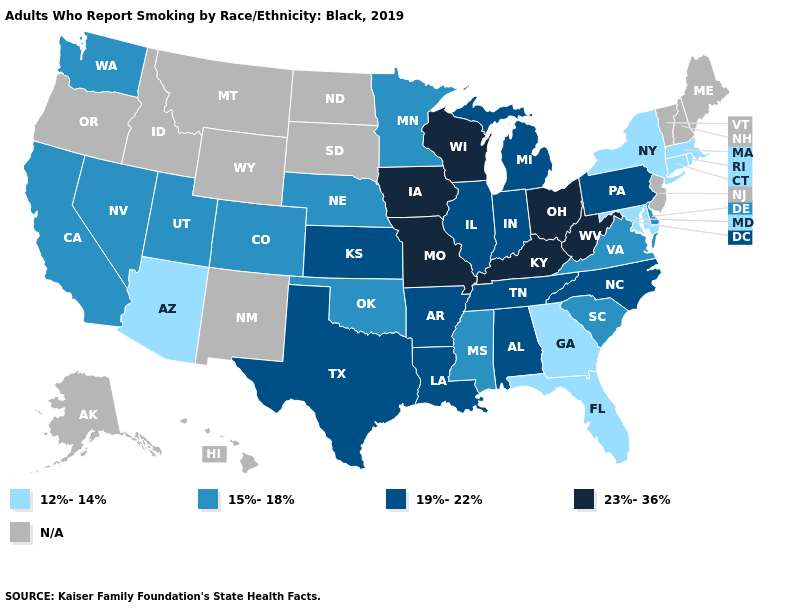Does Kentucky have the lowest value in the USA?
Give a very brief answer. No. Is the legend a continuous bar?
Keep it brief. No. Which states have the highest value in the USA?
Write a very short answer. Iowa, Kentucky, Missouri, Ohio, West Virginia, Wisconsin. Does Pennsylvania have the highest value in the Northeast?
Concise answer only. Yes. Among the states that border Texas , does Louisiana have the highest value?
Short answer required. Yes. Name the states that have a value in the range 12%-14%?
Concise answer only. Arizona, Connecticut, Florida, Georgia, Maryland, Massachusetts, New York, Rhode Island. What is the lowest value in states that border Massachusetts?
Write a very short answer. 12%-14%. Name the states that have a value in the range N/A?
Answer briefly. Alaska, Hawaii, Idaho, Maine, Montana, New Hampshire, New Jersey, New Mexico, North Dakota, Oregon, South Dakota, Vermont, Wyoming. Does Iowa have the highest value in the USA?
Quick response, please. Yes. Name the states that have a value in the range N/A?
Keep it brief. Alaska, Hawaii, Idaho, Maine, Montana, New Hampshire, New Jersey, New Mexico, North Dakota, Oregon, South Dakota, Vermont, Wyoming. What is the highest value in the USA?
Concise answer only. 23%-36%. Which states hav the highest value in the Northeast?
Answer briefly. Pennsylvania. Among the states that border Ohio , does West Virginia have the highest value?
Concise answer only. Yes. 